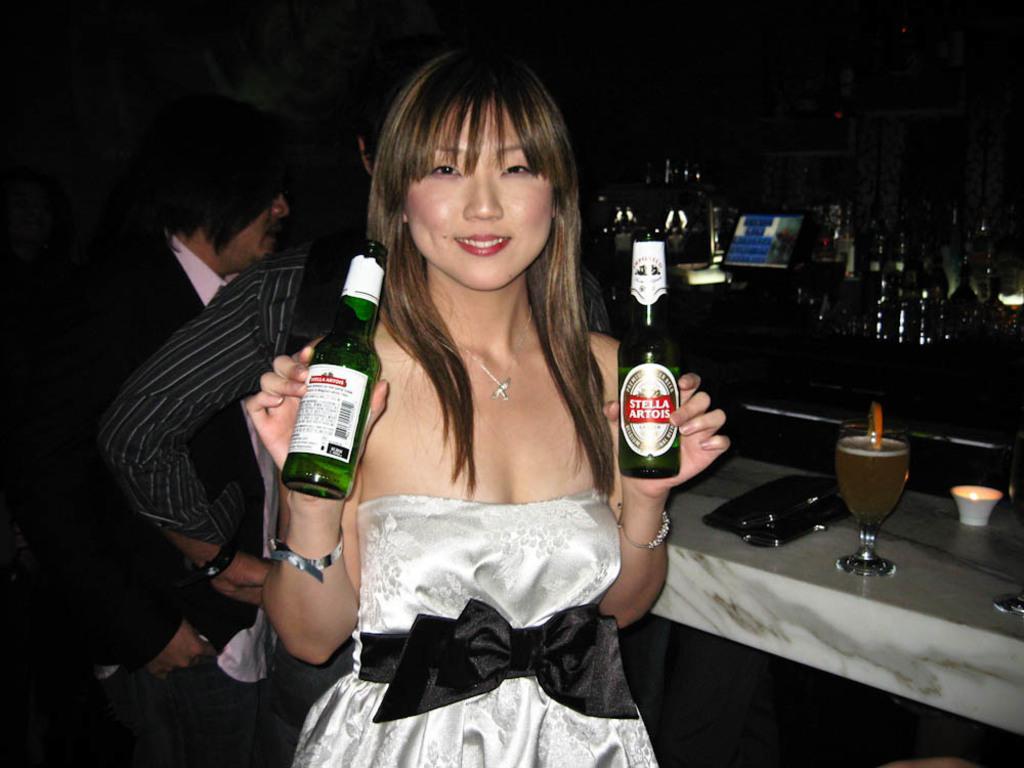In one or two sentences, can you explain what this image depicts? There is a woman standing and holding beer bottles. This is a wine glass and a black color object is placed on the cabin. Here are group of bottle,at background two persons are standing. 